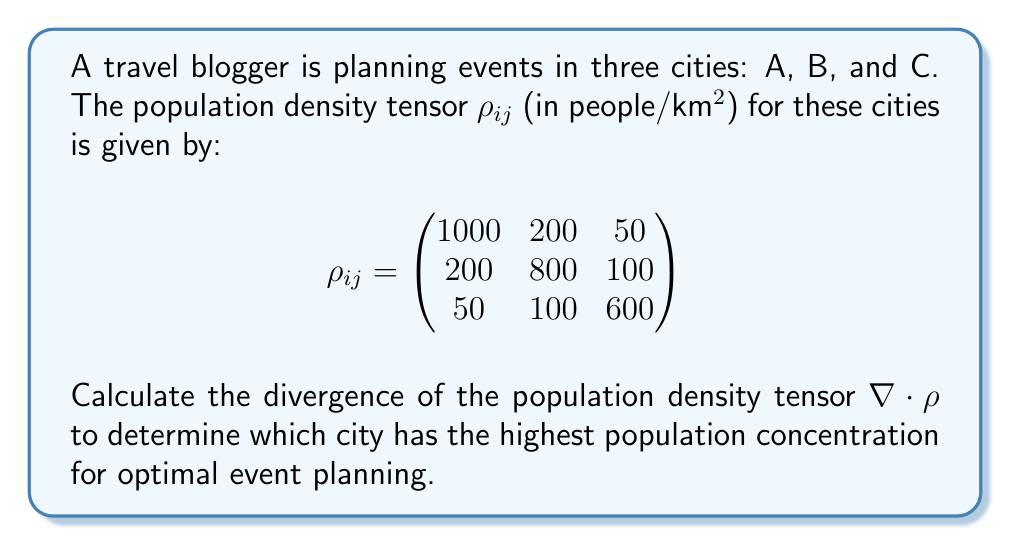Give your solution to this math problem. To solve this problem, we need to calculate the divergence of the population density tensor. The divergence of a tensor is the sum of its diagonal elements.

Step 1: Identify the diagonal elements of the tensor $\rho_{ij}$:
$\rho_{11} = 1000$, $\rho_{22} = 800$, $\rho_{33} = 600$

Step 2: Calculate the divergence using the formula:
$$\nabla \cdot \rho = \sum_{i=1}^3 \rho_{ii}$$

Step 3: Sum the diagonal elements:
$$\nabla \cdot \rho = \rho_{11} + \rho_{22} + \rho_{33} = 1000 + 800 + 600 = 2400$$

Step 4: Interpret the result:
The divergence of 2400 people/km² represents the total population concentration across all three cities. To determine which city has the highest concentration, we compare the diagonal elements:

City A: $\rho_{11} = 1000$ people/km²
City B: $\rho_{22} = 800$ people/km²
City C: $\rho_{33} = 600$ people/km²

City A has the highest population concentration, making it the optimal location for event planning.
Answer: City A (1000 people/km²) 